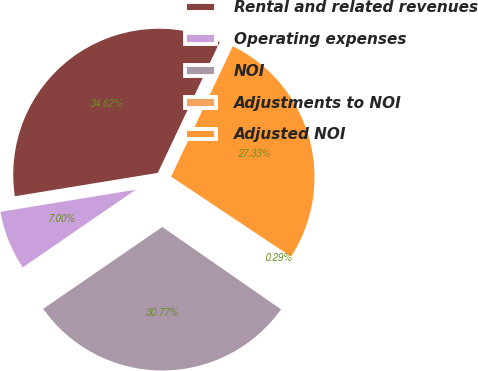Convert chart. <chart><loc_0><loc_0><loc_500><loc_500><pie_chart><fcel>Rental and related revenues<fcel>Operating expenses<fcel>NOI<fcel>Adjustments to NOI<fcel>Adjusted NOI<nl><fcel>34.62%<fcel>7.0%<fcel>30.77%<fcel>0.29%<fcel>27.33%<nl></chart> 